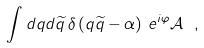Convert formula to latex. <formula><loc_0><loc_0><loc_500><loc_500>\int d q d \widetilde { q } \, \delta \left ( q \widetilde { q } - \alpha \right ) \, e ^ { i \varphi } \mathcal { A } \ ,</formula> 